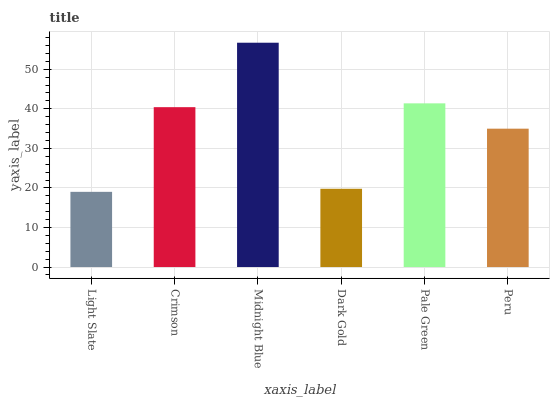Is Light Slate the minimum?
Answer yes or no. Yes. Is Midnight Blue the maximum?
Answer yes or no. Yes. Is Crimson the minimum?
Answer yes or no. No. Is Crimson the maximum?
Answer yes or no. No. Is Crimson greater than Light Slate?
Answer yes or no. Yes. Is Light Slate less than Crimson?
Answer yes or no. Yes. Is Light Slate greater than Crimson?
Answer yes or no. No. Is Crimson less than Light Slate?
Answer yes or no. No. Is Crimson the high median?
Answer yes or no. Yes. Is Peru the low median?
Answer yes or no. Yes. Is Dark Gold the high median?
Answer yes or no. No. Is Midnight Blue the low median?
Answer yes or no. No. 